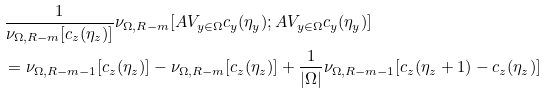<formula> <loc_0><loc_0><loc_500><loc_500>& \frac { 1 } { \nu _ { \Omega , R - m } [ c _ { z } ( \eta _ { z } ) ] } \nu _ { \Omega , R - m } [ A V _ { y \in \Omega } c _ { y } ( \eta _ { y } ) ; A V _ { y \in \Omega } c _ { y } ( \eta _ { y } ) ] \\ & = \nu _ { \Omega , R - m - 1 } [ c _ { z } ( \eta _ { z } ) ] - \nu _ { \Omega , R - m } [ c _ { z } ( \eta _ { z } ) ] + \frac { 1 } { | \Omega | } \nu _ { \Omega , R - m - 1 } [ c _ { z } ( \eta _ { z } + 1 ) - c _ { z } ( \eta _ { z } ) ]</formula> 